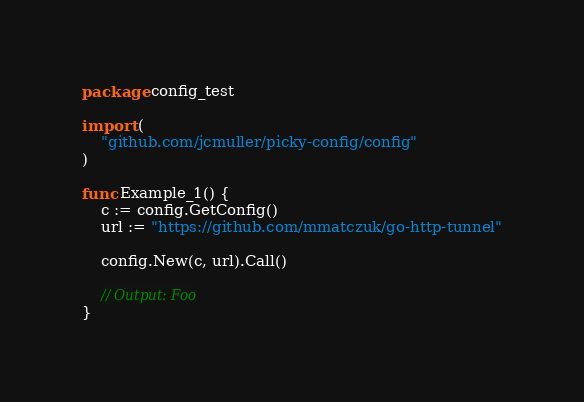<code> <loc_0><loc_0><loc_500><loc_500><_Go_>package config_test

import (
	"github.com/jcmuller/picky-config/config"
)

func Example_1() {
	c := config.GetConfig()
	url := "https://github.com/mmatczuk/go-http-tunnel"

	config.New(c, url).Call()

	// Output: Foo
}
</code> 